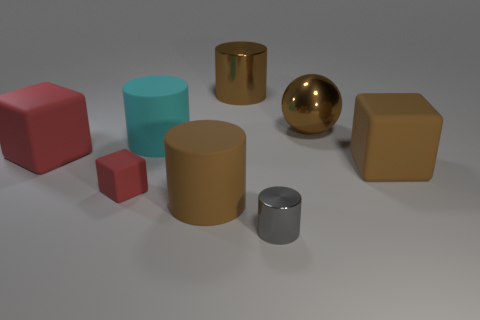Are there any large metallic things that have the same color as the metallic sphere?
Your response must be concise. Yes. What number of small objects are gray things or blue rubber blocks?
Keep it short and to the point. 1. How many big balls are there?
Your response must be concise. 1. What is the small object that is left of the small shiny thing made of?
Provide a succinct answer. Rubber. Are there any large red blocks on the right side of the large brown rubber cylinder?
Make the answer very short. No. Is the gray metallic object the same size as the brown cube?
Provide a short and direct response. No. How many other red objects are made of the same material as the small red object?
Your response must be concise. 1. There is a brown cylinder that is behind the big cube on the left side of the cyan thing; how big is it?
Keep it short and to the point. Large. What color is the large thing that is on the right side of the tiny metal thing and in front of the cyan matte object?
Offer a terse response. Brown. Is the shape of the cyan thing the same as the gray metallic thing?
Make the answer very short. Yes. 